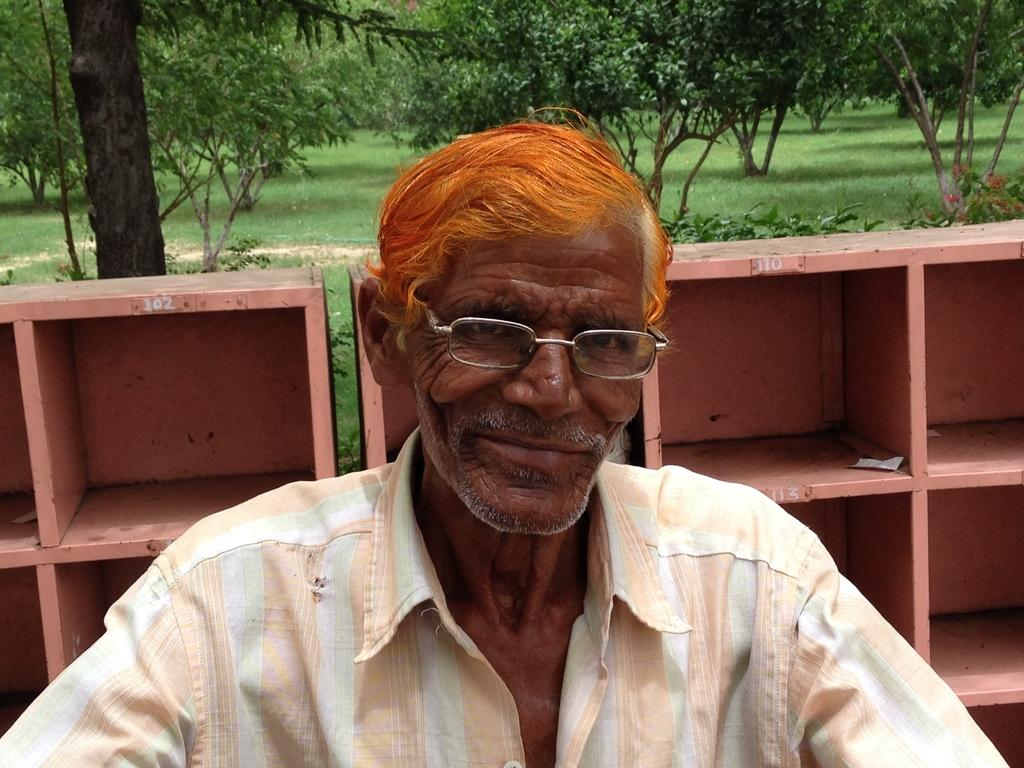Who is present in the image? There is a man in the image. What can be seen in the background of the image? There are trees, the ground, plants, flowers, and cupboards in the background of the image. What type of mint can be seen growing near the cupboards in the image? There is no mint present in the image. 